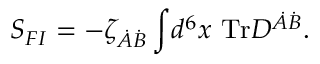<formula> <loc_0><loc_0><loc_500><loc_500>S _ { F I } = - \zeta _ { \dot { A } \dot { B } } \int \, d ^ { 6 } x T r D ^ { \dot { A } \dot { B } } .</formula> 